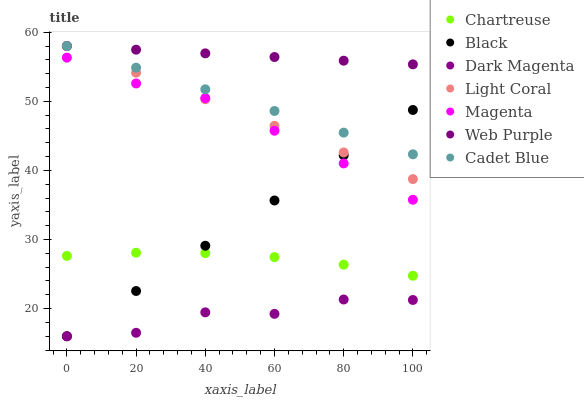Does Dark Magenta have the minimum area under the curve?
Answer yes or no. Yes. Does Web Purple have the maximum area under the curve?
Answer yes or no. Yes. Does Chartreuse have the minimum area under the curve?
Answer yes or no. No. Does Chartreuse have the maximum area under the curve?
Answer yes or no. No. Is Cadet Blue the smoothest?
Answer yes or no. Yes. Is Dark Magenta the roughest?
Answer yes or no. Yes. Is Chartreuse the smoothest?
Answer yes or no. No. Is Chartreuse the roughest?
Answer yes or no. No. Does Dark Magenta have the lowest value?
Answer yes or no. Yes. Does Chartreuse have the lowest value?
Answer yes or no. No. Does Web Purple have the highest value?
Answer yes or no. Yes. Does Chartreuse have the highest value?
Answer yes or no. No. Is Dark Magenta less than Light Coral?
Answer yes or no. Yes. Is Cadet Blue greater than Magenta?
Answer yes or no. Yes. Does Black intersect Light Coral?
Answer yes or no. Yes. Is Black less than Light Coral?
Answer yes or no. No. Is Black greater than Light Coral?
Answer yes or no. No. Does Dark Magenta intersect Light Coral?
Answer yes or no. No. 